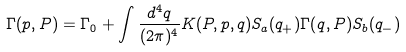Convert formula to latex. <formula><loc_0><loc_0><loc_500><loc_500>\Gamma ( p , P ) = \Gamma _ { 0 } + \int \frac { d ^ { 4 } q } { ( 2 \pi ) ^ { 4 } } K ( P , p , q ) S _ { a } ( q _ { + } ) \Gamma ( q , P ) S _ { b } ( q _ { - } )</formula> 